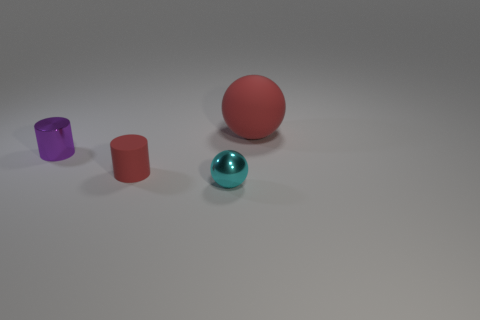Add 3 small green metallic blocks. How many objects exist? 7 Subtract all tiny shiny cylinders. Subtract all gray metallic spheres. How many objects are left? 3 Add 1 purple metal objects. How many purple metal objects are left? 2 Add 4 tiny green cubes. How many tiny green cubes exist? 4 Subtract 0 gray cylinders. How many objects are left? 4 